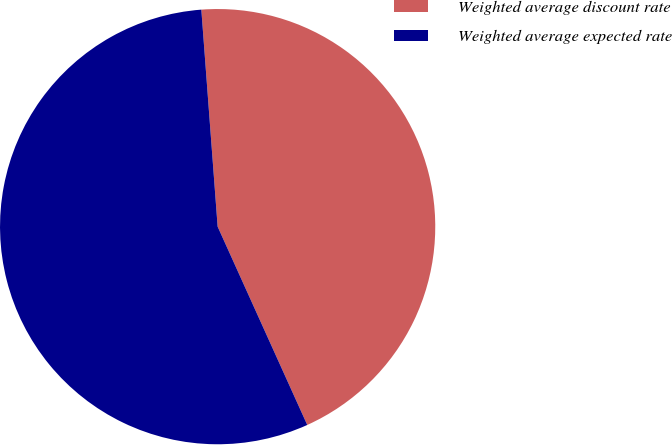Convert chart. <chart><loc_0><loc_0><loc_500><loc_500><pie_chart><fcel>Weighted average discount rate<fcel>Weighted average expected rate<nl><fcel>44.44%<fcel>55.56%<nl></chart> 